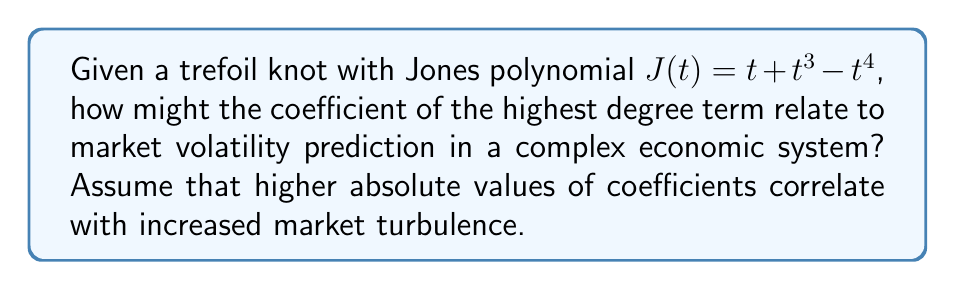Solve this math problem. To analyze the Jones polynomial and its economic implications for market volatility prediction, we'll follow these steps:

1) First, let's identify the highest degree term in the given Jones polynomial:
   $J(t) = t + t^3 - t^4$
   The highest degree term is $-t^4$

2) The coefficient of the highest degree term is -1.

3) In knot theory, the highest degree term of the Jones polynomial often carries significant information about the knot's complexity. In our economic interpretation, we're assuming that this complexity translates to market turbulence.

4) The absolute value of the coefficient is |−1| = 1.

5) Given our assumption that higher absolute values of coefficients correlate with increased market turbulence, a coefficient of 1 suggests a moderate level of market volatility.

6) In economic terms, this could be interpreted as:
   - The market is not in a state of extreme volatility (which might be indicated by a larger coefficient)
   - However, there is some level of turbulence present, as the coefficient is non-zero

7) For a seasoned economist advising multinational corporations on risk mitigation:
   - This moderate volatility suggests a need for balanced risk management strategies
   - It may indicate a market that is neither overly stable nor extremely volatile, requiring careful monitoring and adaptive strategies

8) In practice, this analysis would be combined with other economic indicators to form a comprehensive market volatility prediction model.
Answer: Moderate market volatility 